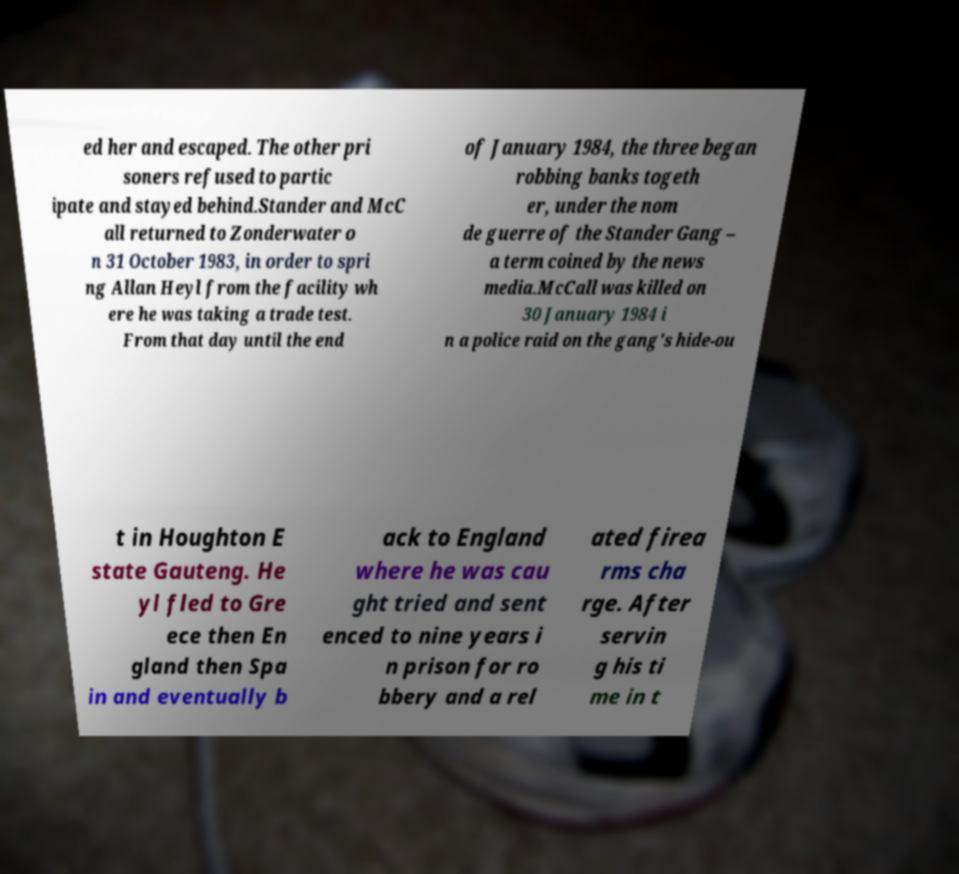Please read and relay the text visible in this image. What does it say? ed her and escaped. The other pri soners refused to partic ipate and stayed behind.Stander and McC all returned to Zonderwater o n 31 October 1983, in order to spri ng Allan Heyl from the facility wh ere he was taking a trade test. From that day until the end of January 1984, the three began robbing banks togeth er, under the nom de guerre of the Stander Gang – a term coined by the news media.McCall was killed on 30 January 1984 i n a police raid on the gang's hide-ou t in Houghton E state Gauteng. He yl fled to Gre ece then En gland then Spa in and eventually b ack to England where he was cau ght tried and sent enced to nine years i n prison for ro bbery and a rel ated firea rms cha rge. After servin g his ti me in t 